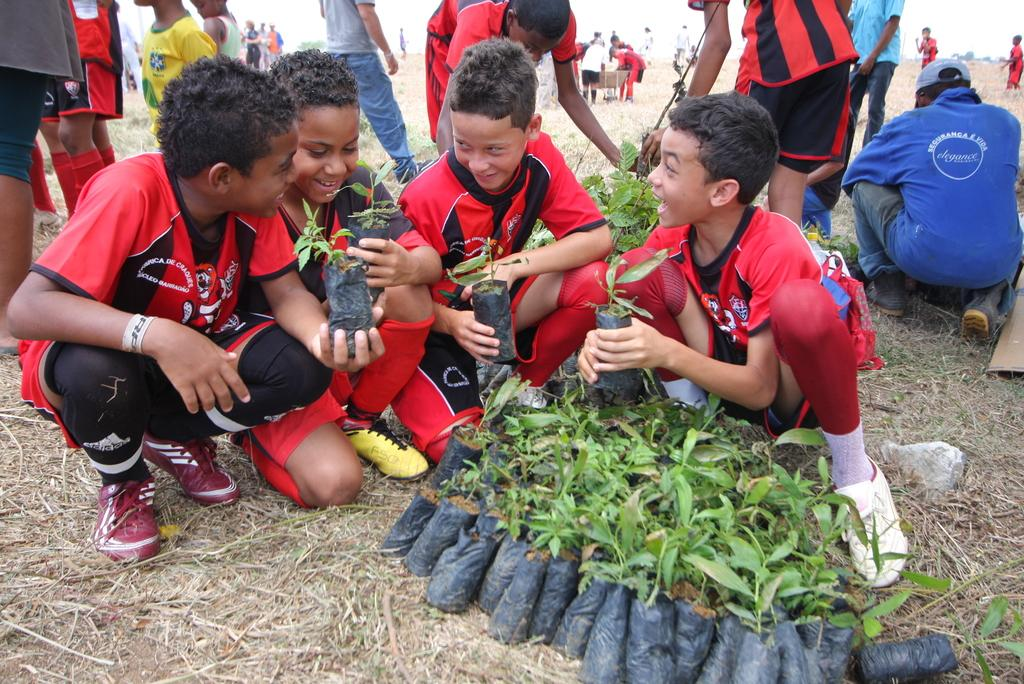How many children are present in the image? There are four children in the image. What are the children holding in the image? The children are holding plants in the image. What is on the ground in the image? There are plants on the ground in the image. Can you describe the background of the image? There are people visible in the background of the image. What type of patch is being used to make the cheese in the image? There is no patch or cheese present in the image; it features four children holding plants. What type of battle is taking place in the image? There is no battle present in the image; it features four children holding plants and people in the background. 